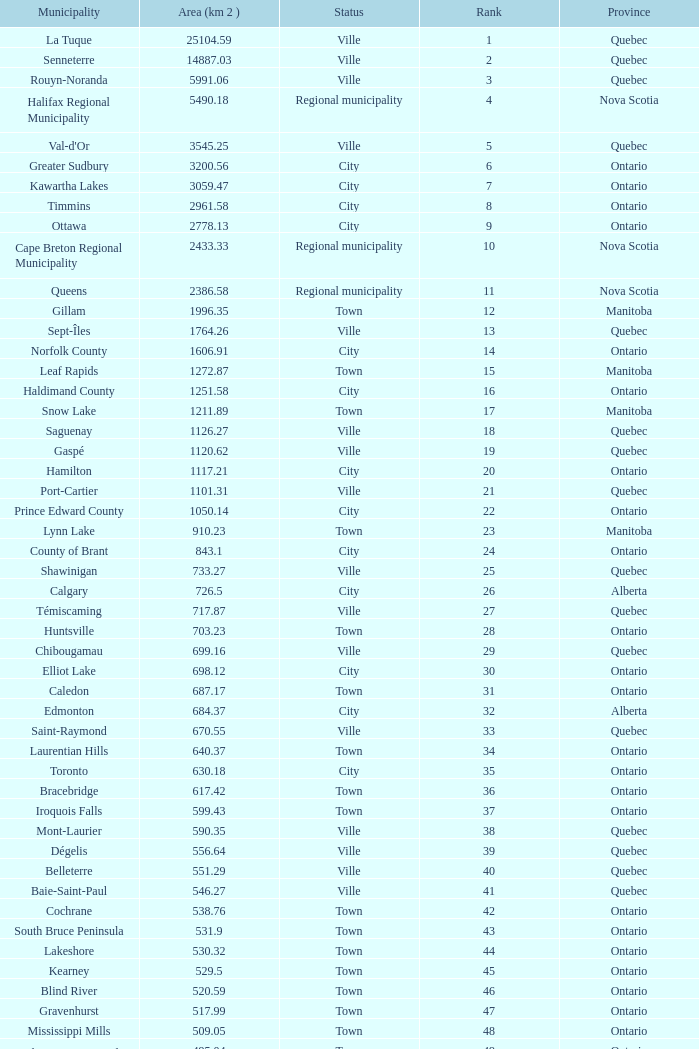What is the total Rank that has a Municipality of Winnipeg, an Area (KM 2) that's larger than 464.01? None. 